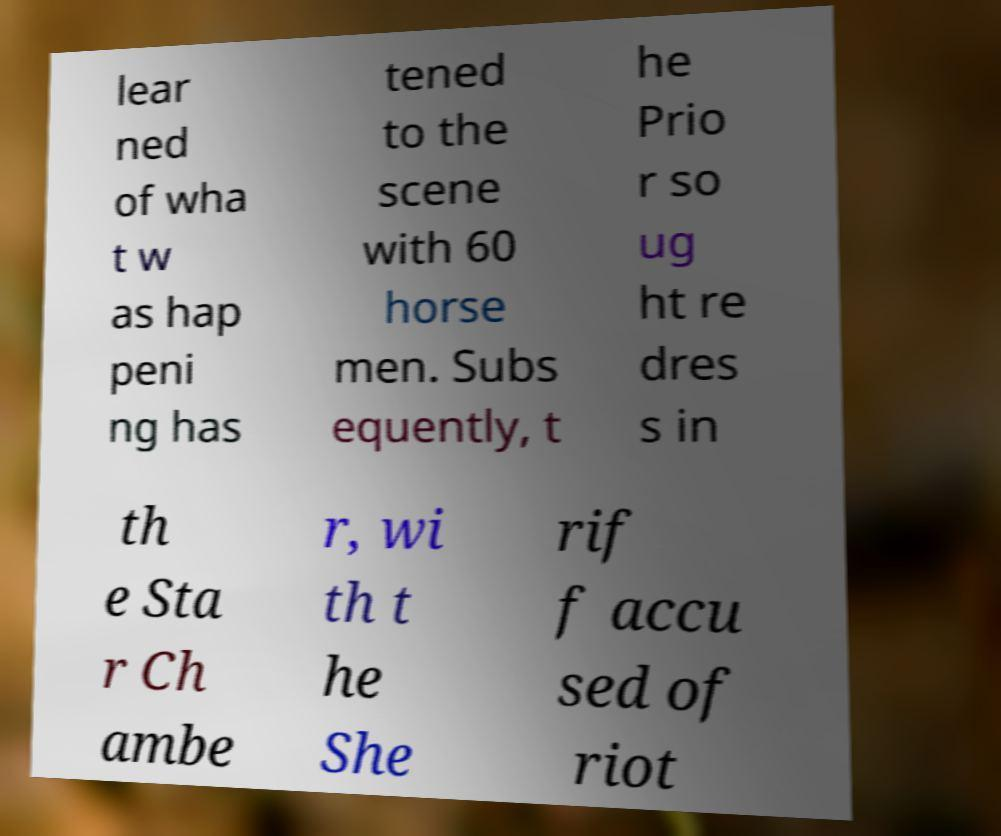Can you read and provide the text displayed in the image?This photo seems to have some interesting text. Can you extract and type it out for me? lear ned of wha t w as hap peni ng has tened to the scene with 60 horse men. Subs equently, t he Prio r so ug ht re dres s in th e Sta r Ch ambe r, wi th t he She rif f accu sed of riot 